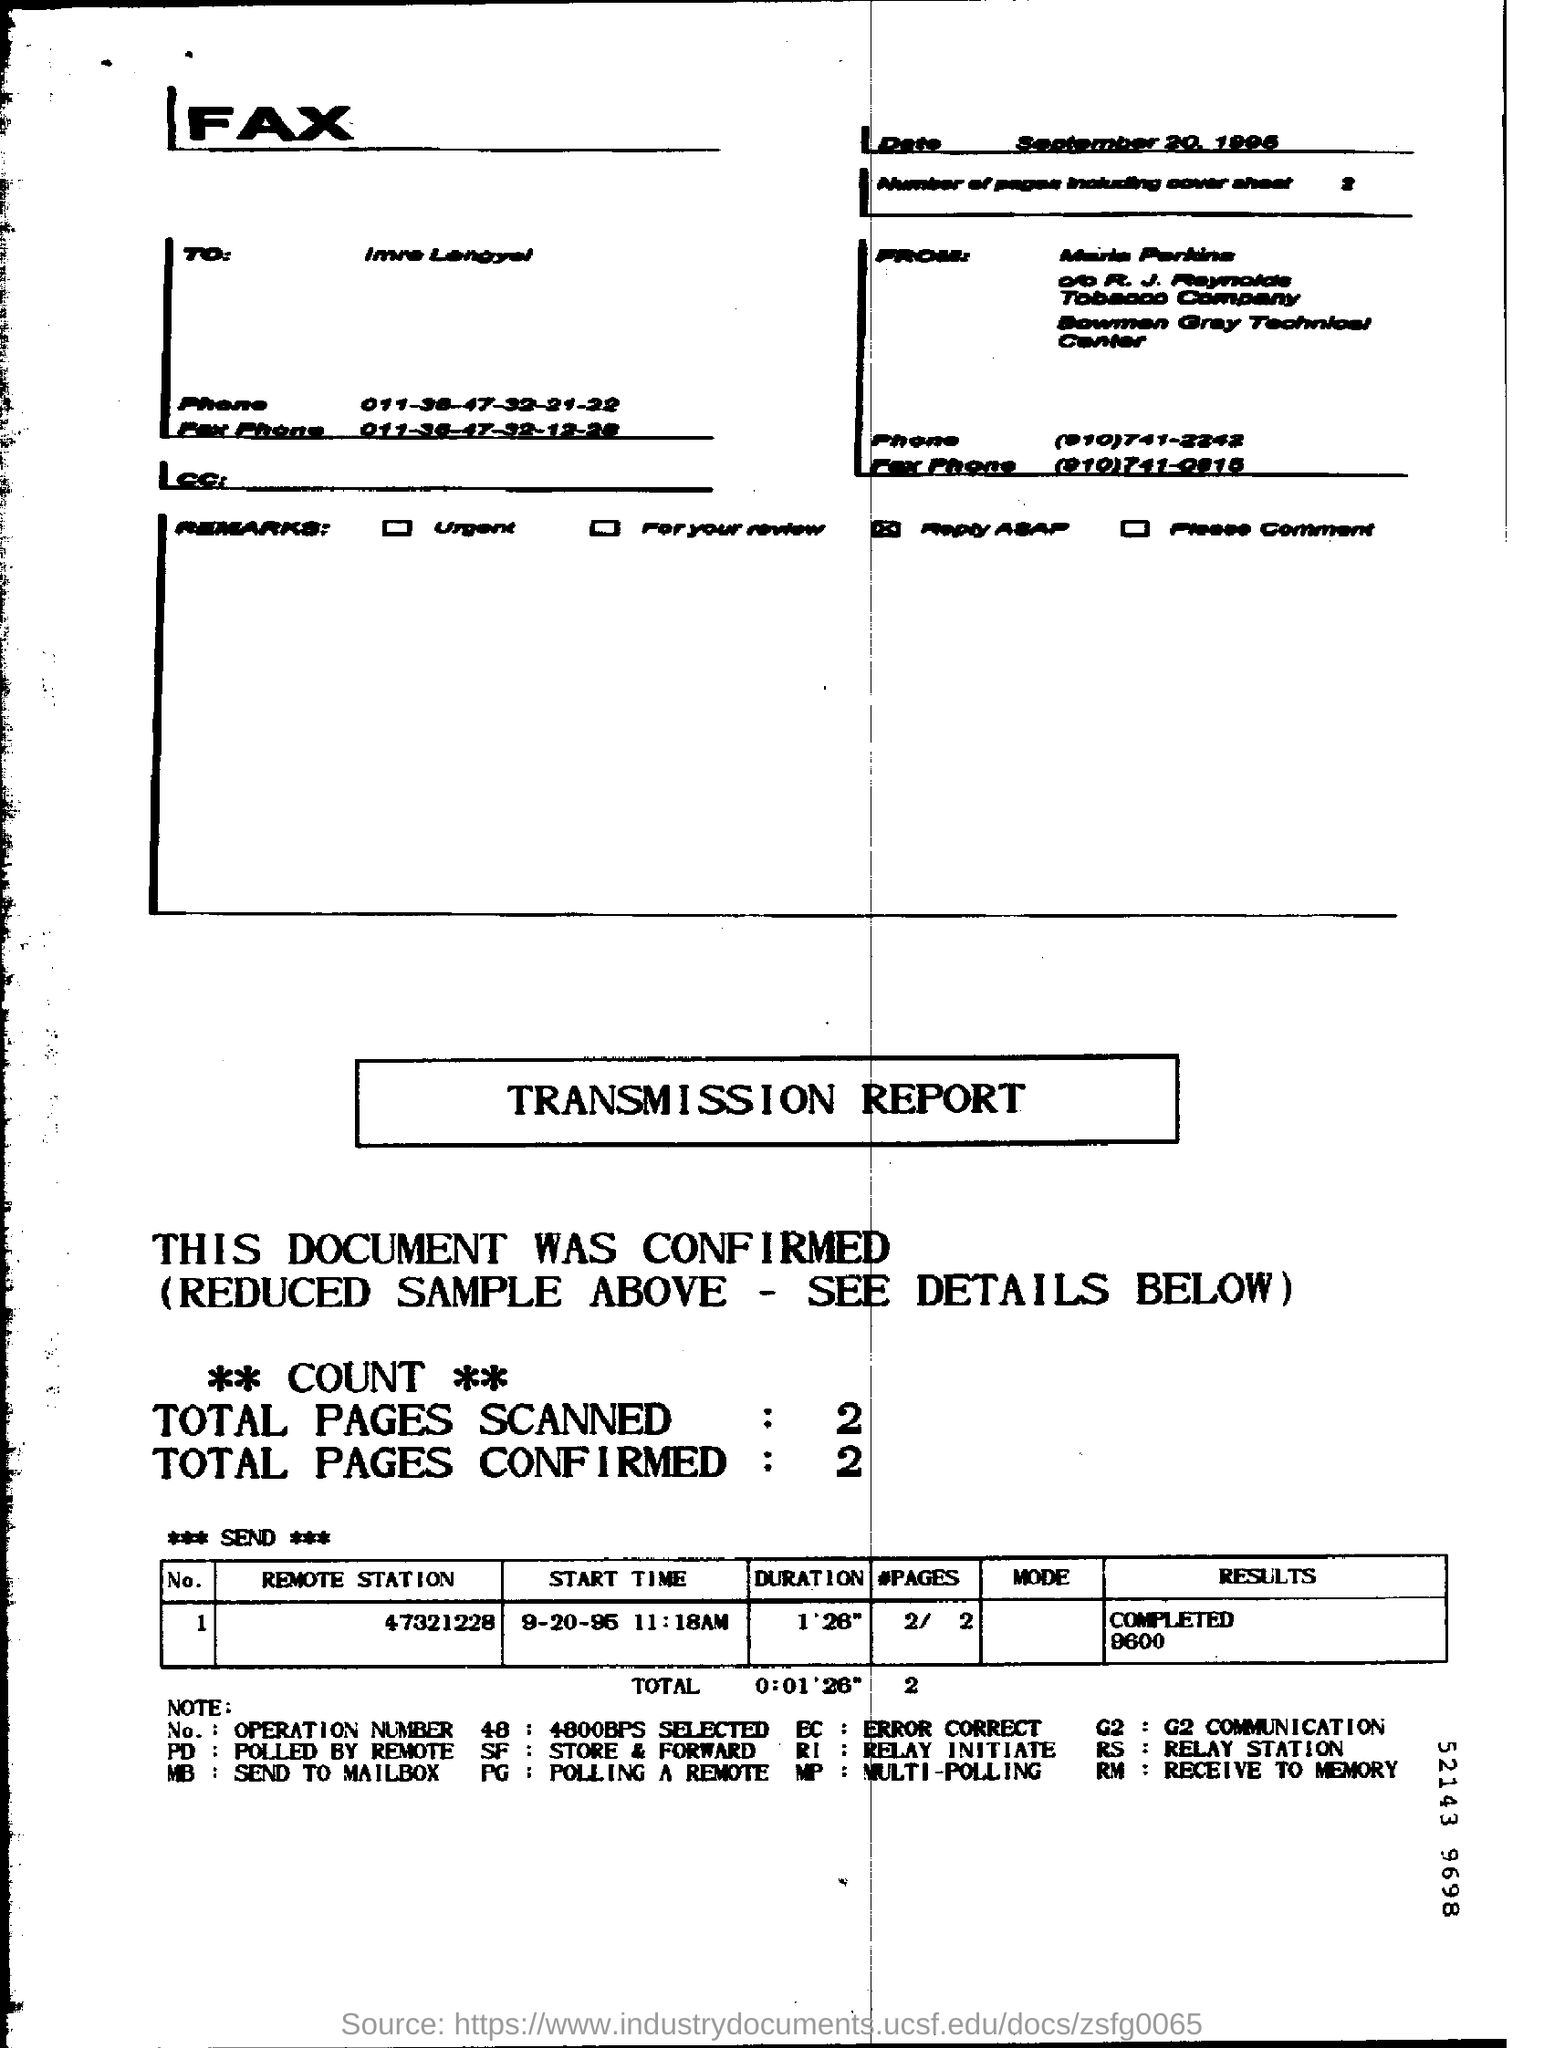What is the Date?
Your answer should be compact. September 20, 1995. What is the "Duration" for "Remote station" "47321228"?
Offer a terse response. 1'26". What is the "Results" for "Remote station" "47321228"?
Ensure brevity in your answer.  COMPLETED 9600. What are the Total Pages Scanned?
Offer a very short reply. 2. What are the Total Pages Confirmed?
Keep it short and to the point. 2. 